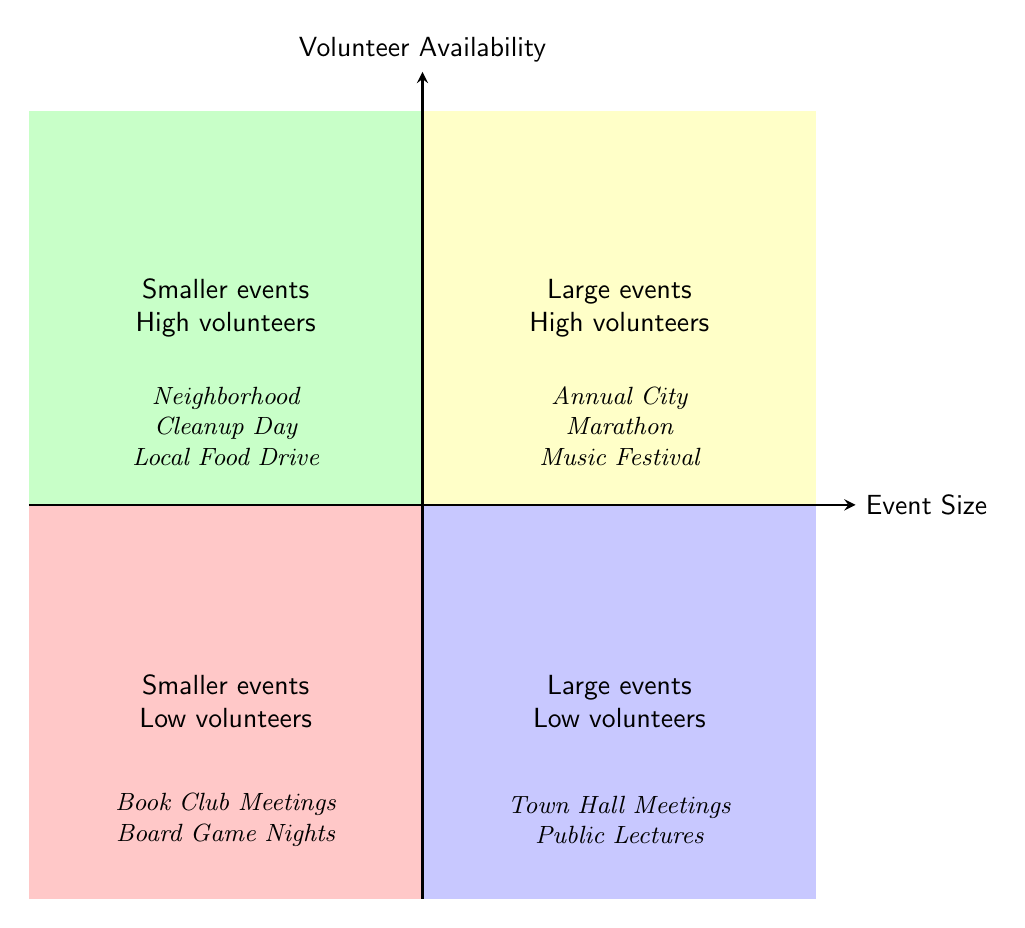What are examples of large community events with high volunteers? The quadrant labeled "Large events High volunteers" contains examples like the Annual City Marathon and Music Festival, which are specifically listed within that section of the diagram.
Answer: Annual City Marathon, Music Festival How many examples are there in the quadrant for smaller events with low volunteers? The quadrant labeled "Smaller events Low volunteers" contains two examples: Book Club Meetings and Board Game Nights, leading to a total of two examples in this quadrant.
Answer: 2 What is the description of smaller community events with a high number of volunteers? The quadrant labeled "Smaller events High volunteers" describes events as smaller community gatherings that involve a high number of volunteers, which encompasses activities like Neighborhood Cleanup Day and Local Food Drive.
Answer: Smaller community events with a high number of volunteers Which quadrant includes Town Hall Meetings? The Town Hall Meetings are found in the quadrant designated as "Large events Low volunteers," indicating that it represents large community events with a low number of volunteers.
Answer: Large events Low volunteers How do the types of events differ in the high-volunteers sections compared to the low-volunteers sections? The high-volunteers sections include activities that engage more people (like marathons and community drives), while the low-volunteers sections include activities that engage fewer people (like meetings and informal gatherings), illustrating a relationship between event size and volunteer availability.
Answer: High-volunteers vs. low-volunteers 